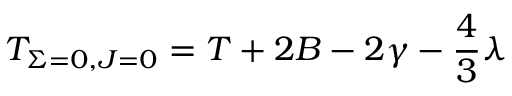<formula> <loc_0><loc_0><loc_500><loc_500>T _ { { \Sigma } = 0 , J = 0 } = T + 2 B - 2 { \gamma } - \frac { 4 } { 3 } { \lambda }</formula> 